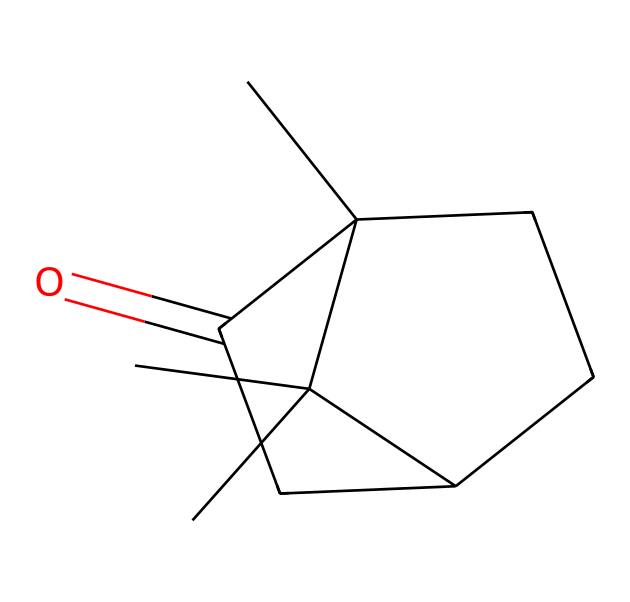What is the molecular weight of camphor? The molecular weight can be calculated by summing the atomic weights of all atoms present in the structure: 10 carbon (C) atoms contribute approximately 120 amu, 16 hydrogen (H) atoms add around 16 amu, and 1 oxygen (O) atom adds about 16 amu. Thus, the total molecular weight is approximately 152 amu.
Answer: 152 amu How many rings are present in camphor? The structure includes a bicyclic arrangement, which means there are two interconnected rings. Counting the distinct cycles visible reveals that there are two complete rings in the camphor structure.
Answer: 2 What functional group is present in camphor? The presence of the carbonyl group (C=O) in the structure can be observed, which classifies camphor as having a ketone functional group since it is located between two carbon atoms in a cyclic acid structure.
Answer: ketone What is the total number of carbon atoms in the camphor molecule? By examining the SMILES structure provided, there are 10 carbon atoms total that can be counted from the notation, indicating the compound's structure is consistent with the carbon count.
Answer: 10 Is camphor a saturated or unsaturated compound? The presence of only single bonds in the ring structure indicates that there are no double bonds present, meaning camphor is fully saturated. This is characteristic of cycloalkanes, confirming it is a saturated compound.
Answer: saturated Identify the type of cycloalkane camphor represents. Given the structure features rings and additional groups like the carbonyl, camphor can be classified as a bicyclic cycloalkane with ketone properties, making it a compound that includes both elements of cycloalkanes and functional groups.
Answer: bicyclic 